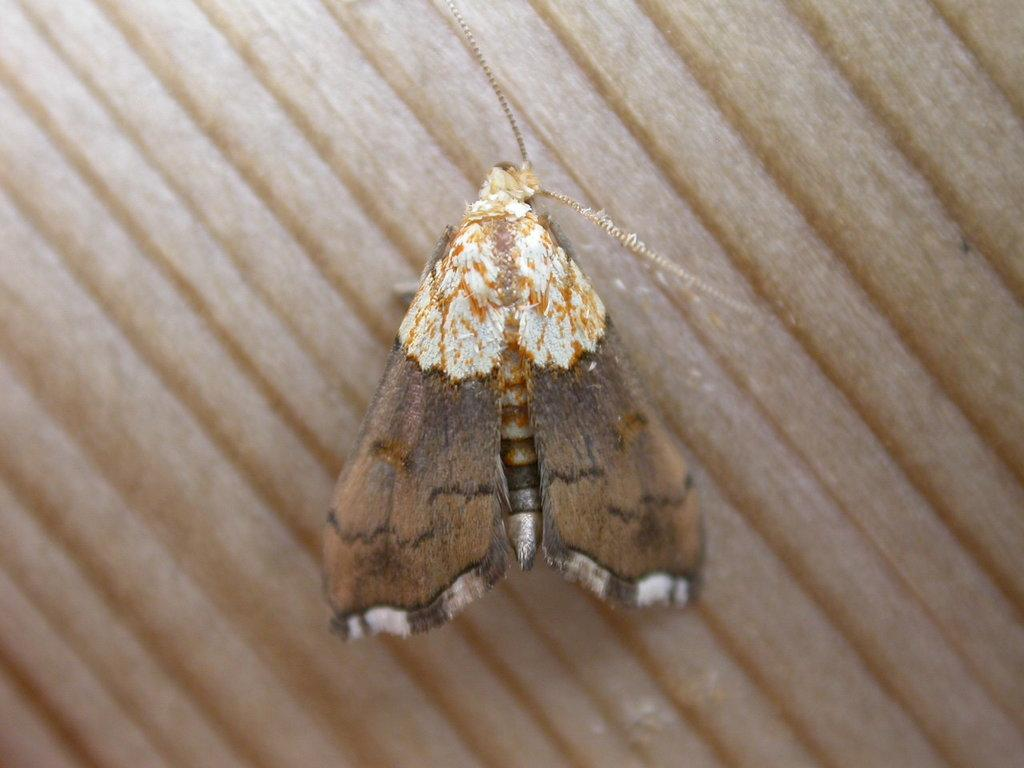What is present on the table in the image? There is a fly on the table in the image. Can you describe the fly's location on the table? The fly is on the table in the image. What type of desk is visible in the image? There is no desk present in the image; it only features a fly on a table. 